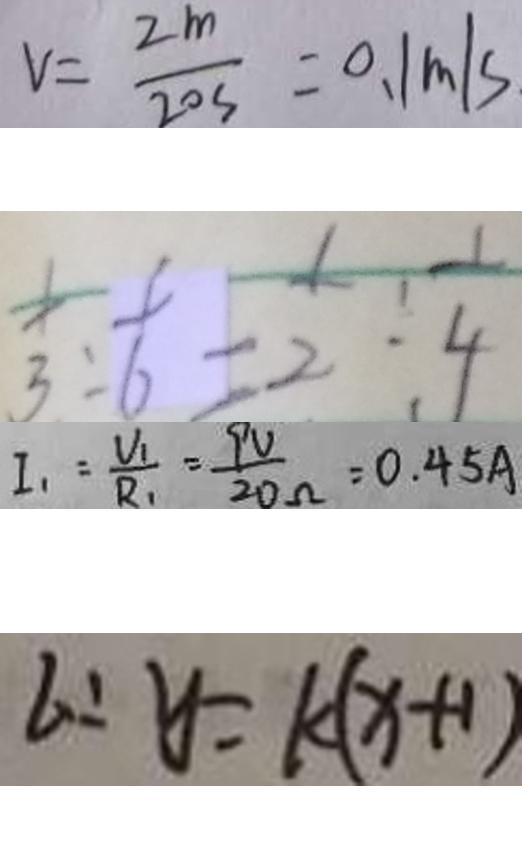Convert formula to latex. <formula><loc_0><loc_0><loc_500><loc_500>V = \frac { 2 m } { 2 0 s } = 0 . 1 m / s 
 \frac { 1 } { 3 } : \frac { 1 } { 6 } = \frac { 1 } { 2 } : \frac { 1 } { 4 } 
 I _ { 1 } = \frac { V _ { 1 } } { R _ { 1 } } = \frac { 9 V } { 2 0 \Omega } = 0 . 4 5 A 
 l : y = k ( x + 1 )</formula> 